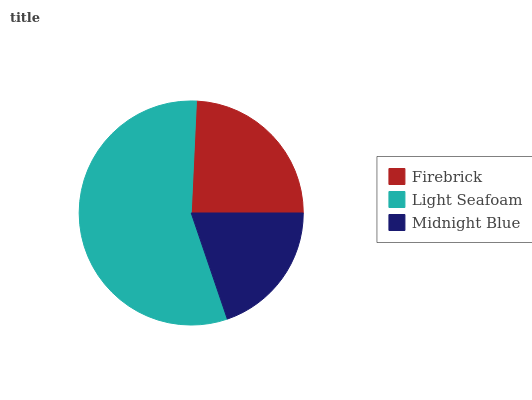Is Midnight Blue the minimum?
Answer yes or no. Yes. Is Light Seafoam the maximum?
Answer yes or no. Yes. Is Light Seafoam the minimum?
Answer yes or no. No. Is Midnight Blue the maximum?
Answer yes or no. No. Is Light Seafoam greater than Midnight Blue?
Answer yes or no. Yes. Is Midnight Blue less than Light Seafoam?
Answer yes or no. Yes. Is Midnight Blue greater than Light Seafoam?
Answer yes or no. No. Is Light Seafoam less than Midnight Blue?
Answer yes or no. No. Is Firebrick the high median?
Answer yes or no. Yes. Is Firebrick the low median?
Answer yes or no. Yes. Is Light Seafoam the high median?
Answer yes or no. No. Is Midnight Blue the low median?
Answer yes or no. No. 